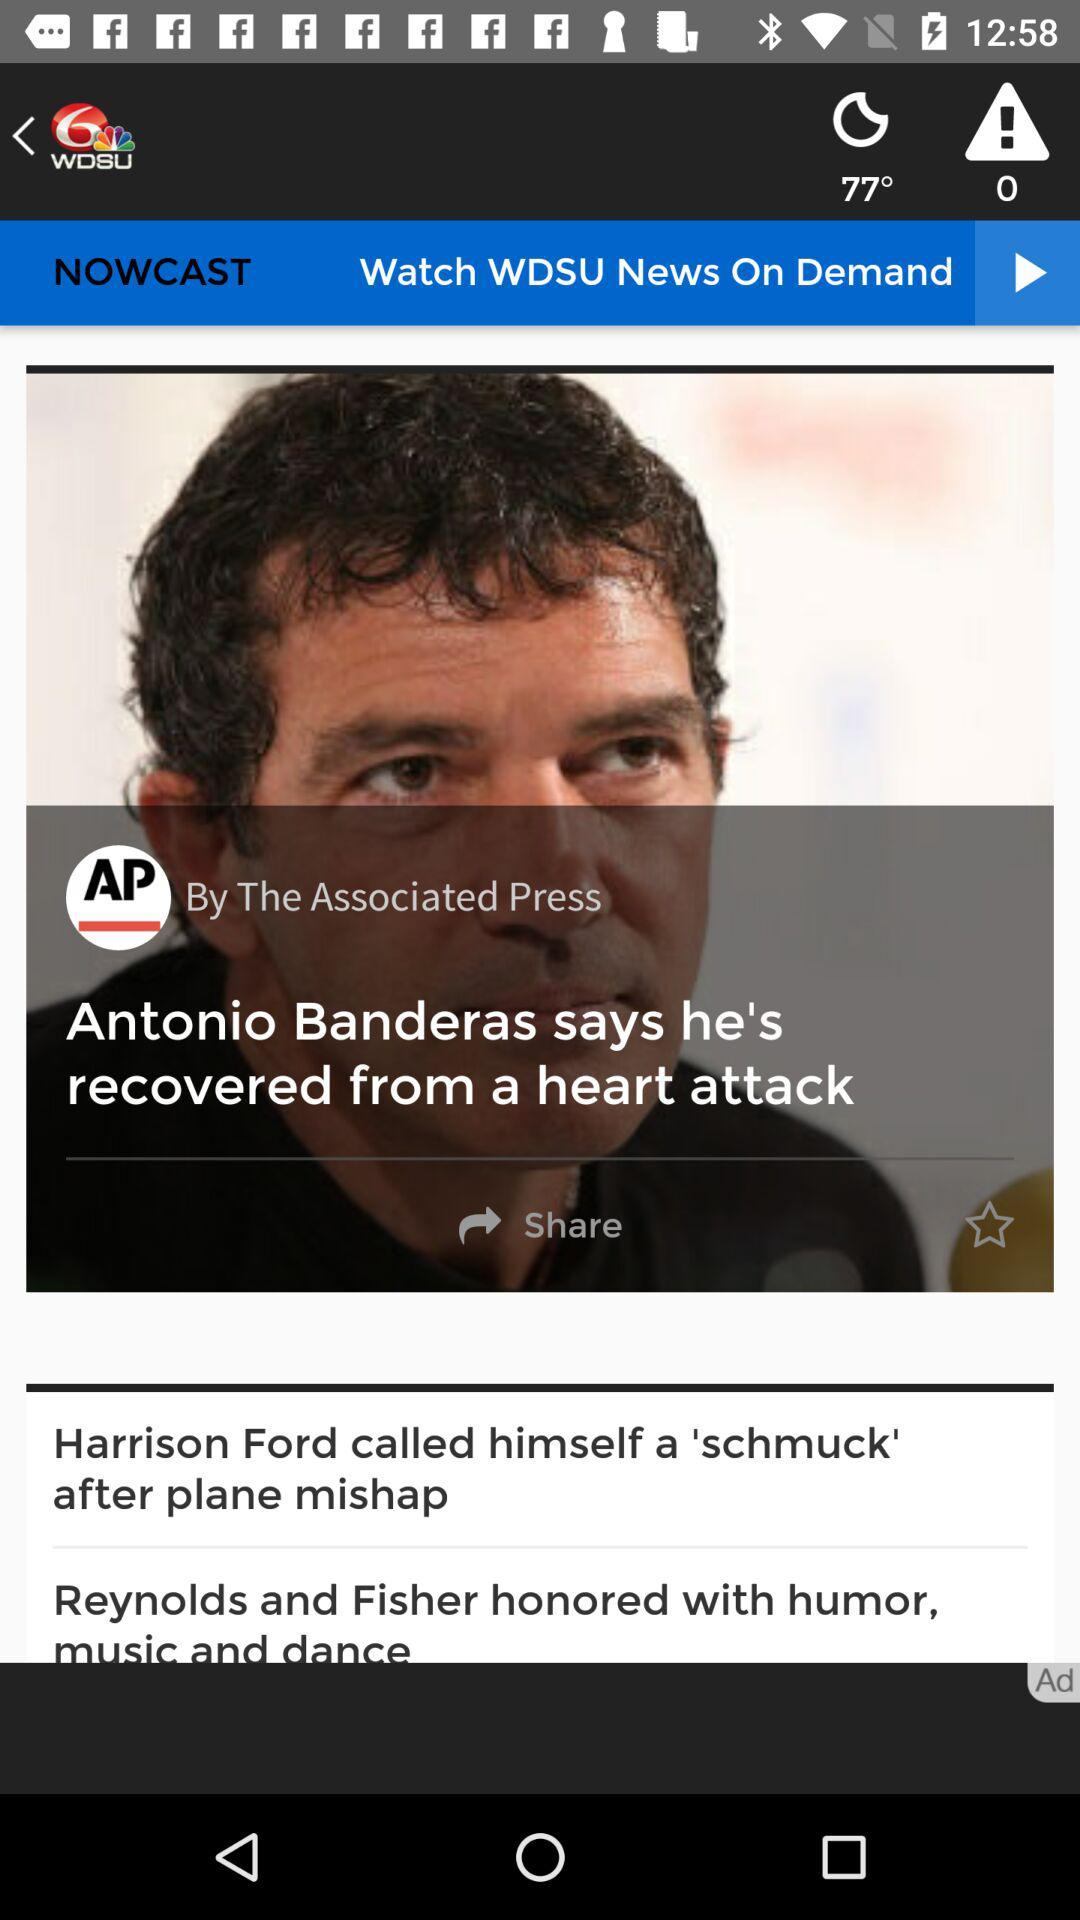What is the temperature shown on the screen? The temperature shown on the screen is 77°. 